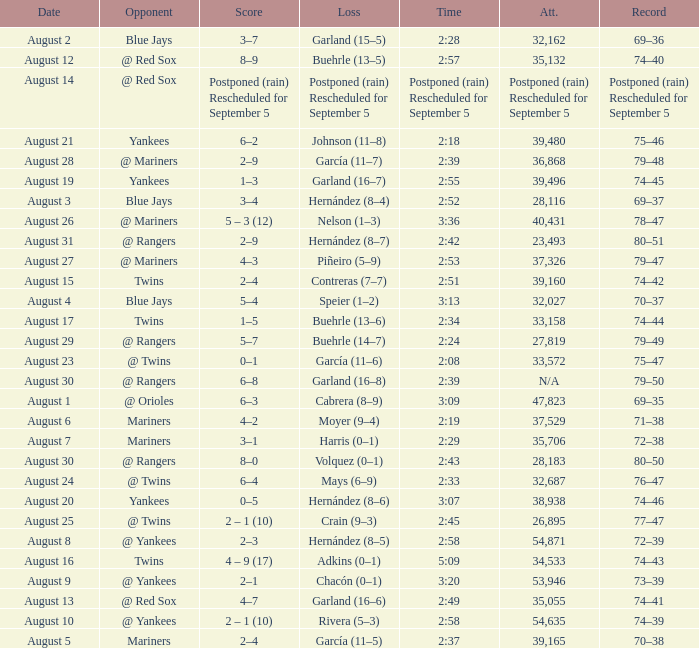Who lost on August 27? Piñeiro (5–9). 